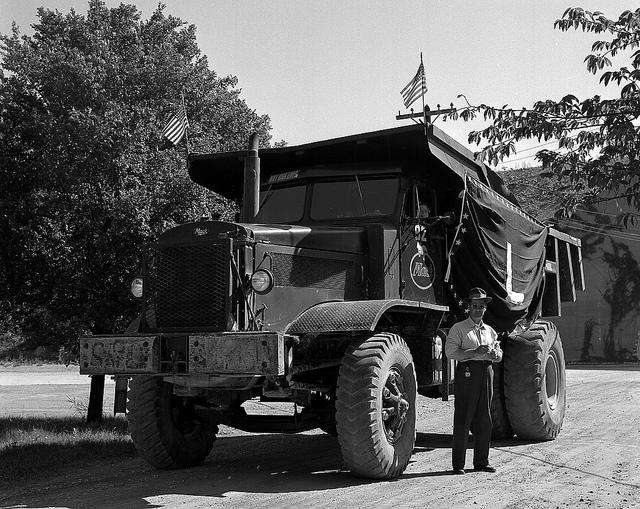Are the truck tires taller than the man?
Be succinct. No. Is this vehicle meant for utility or transportation?
Answer briefly. Utility. Is this photo vintage?
Quick response, please. Yes. 